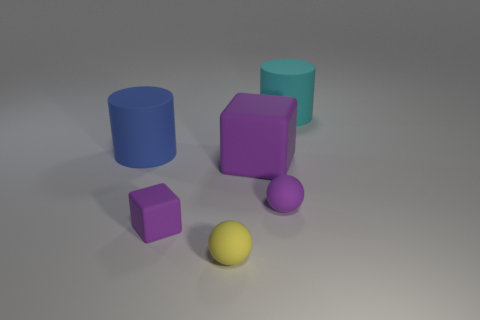Are there any blue cylinders that have the same size as the cyan matte cylinder? Yes, there is one blue cylinder that matches the size of the cyan matte cylinder shown in the image. 